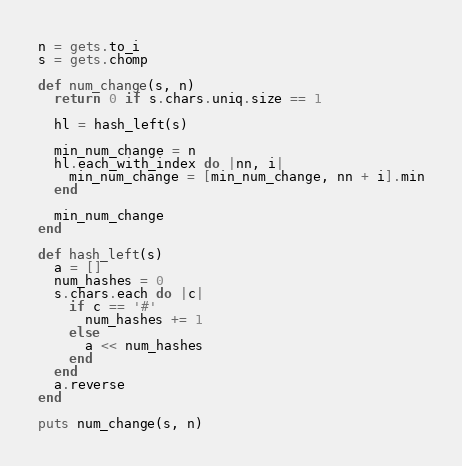<code> <loc_0><loc_0><loc_500><loc_500><_Ruby_>n = gets.to_i
s = gets.chomp

def num_change(s, n)
  return 0 if s.chars.uniq.size == 1

  hl = hash_left(s)

  min_num_change = n
  hl.each_with_index do |nn, i|
    min_num_change = [min_num_change, nn + i].min
  end

  min_num_change
end

def hash_left(s)
  a = []
  num_hashes = 0
  s.chars.each do |c|
    if c == '#'
      num_hashes += 1
    else
      a << num_hashes
    end
  end
  a.reverse
end

puts num_change(s, n)</code> 